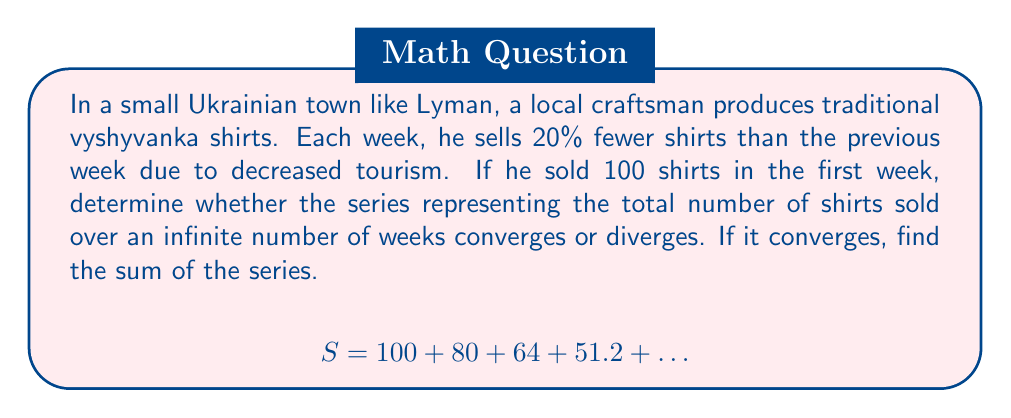Help me with this question. Let's approach this step-by-step:

1) First, we need to identify this as a geometric series. The general form of a geometric series is:

   $$a + ar + ar^2 + ar^3 + ...$$

   where $a$ is the first term and $r$ is the common ratio.

2) In this case:
   $a = 100$ (first term)
   $r = 0.8$ (each term is 80% of the previous, or 20% less)

3) For a geometric series to converge, we need $|r| < 1$. Here, $|r| = 0.8 < 1$, so the series converges.

4) For a convergent geometric series, the sum is given by the formula:

   $$S_{\infty} = \frac{a}{1-r}$$

5) Substituting our values:

   $$S_{\infty} = \frac{100}{1-0.8} = \frac{100}{0.2} = 500$$

Therefore, the series converges, and the sum represents the total number of shirts sold over an infinite number of weeks, which is 500 shirts.
Answer: Converges; Sum = 500 shirts 